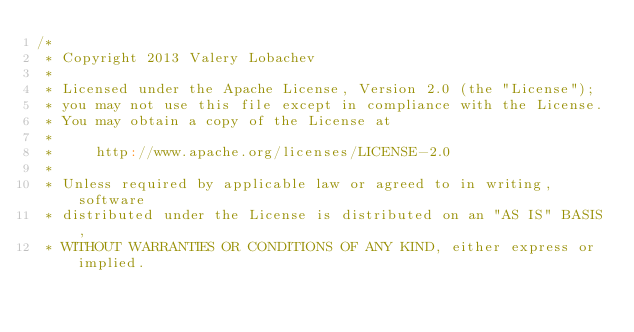Convert code to text. <code><loc_0><loc_0><loc_500><loc_500><_Scala_>/*
 * Copyright 2013 Valery Lobachev
 *
 * Licensed under the Apache License, Version 2.0 (the "License");
 * you may not use this file except in compliance with the License.
 * You may obtain a copy of the License at
 *
 *     http://www.apache.org/licenses/LICENSE-2.0
 *
 * Unless required by applicable law or agreed to in writing, software
 * distributed under the License is distributed on an "AS IS" BASIS,
 * WITHOUT WARRANTIES OR CONDITIONS OF ANY KIND, either express or implied.</code> 